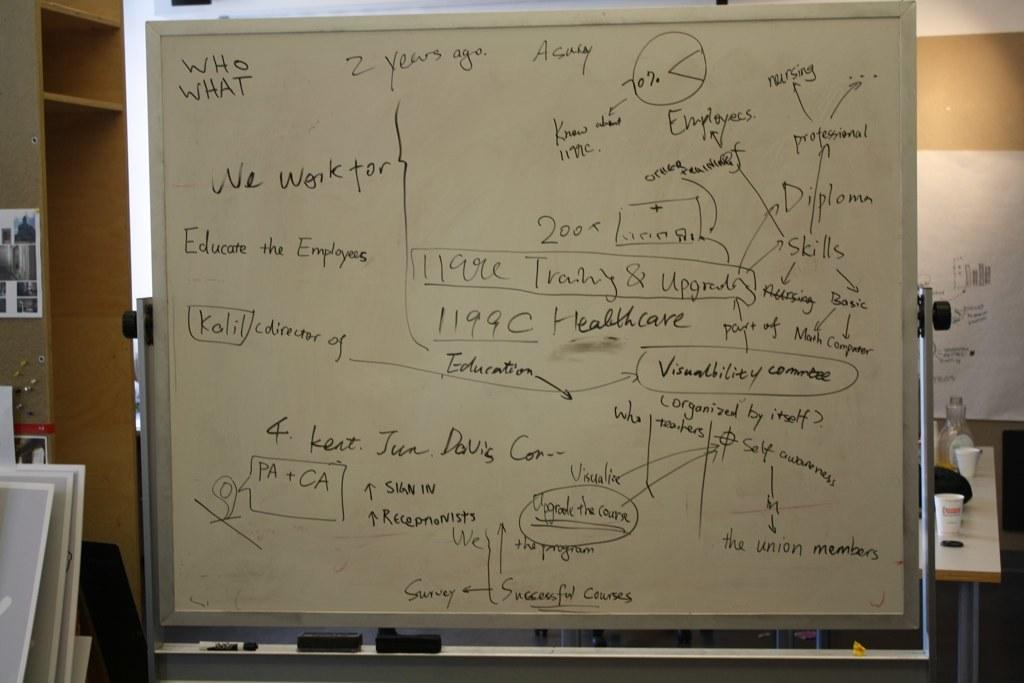<image>
Create a compact narrative representing the image presented. whiteboard with words and flowchart type labeling and words who what at top corner 